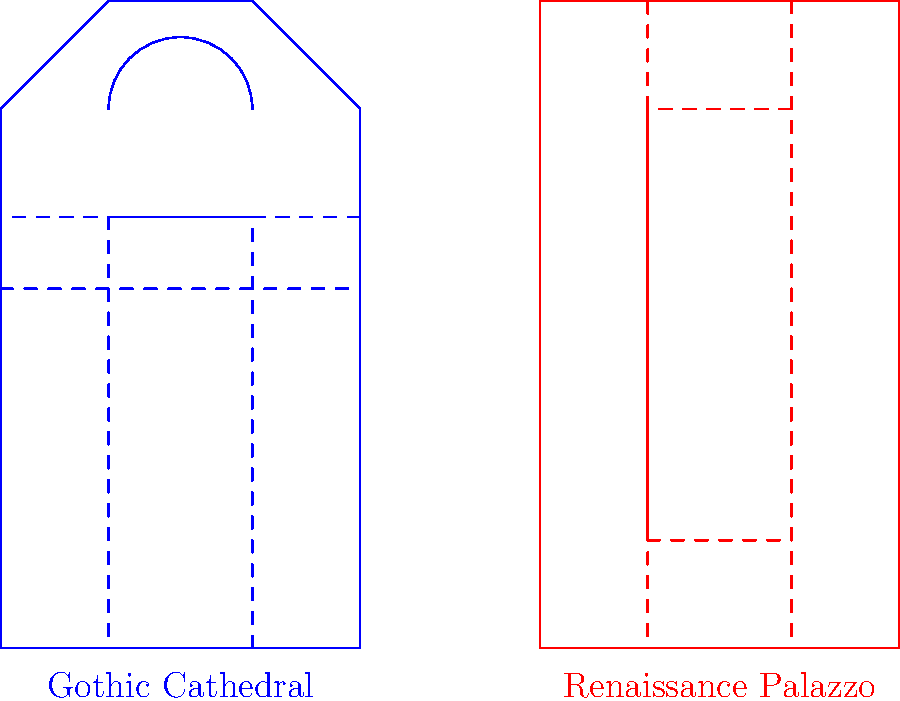Compare and contrast the floor plans of the Gothic Cathedral (left) and the Renaissance Palazzo (right) shown in the diagram. How do these architectural layouts reflect the cultural and societal values of their respective time periods? Discuss at least three key differences in their spatial organization and overall design philosophy. To compare and contrast these floor plans, we need to consider several key aspects:

1. Overall Shape:
   - Gothic Cathedral: Cruciform shape with a long nave, transepts, and apse.
   - Renaissance Palazzo: Rectangular shape with a central courtyard.

2. Spatial Organization:
   - Gothic Cathedral: 
     a) Linear progression from entrance to altar
     b) Hierarchical spaces (nave, transepts, apse)
     c) Emphasis on vertical space (not shown in plan, but implied)
   - Renaissance Palazzo:
     a) Rooms arranged around a central courtyard
     b) More equal distribution of spaces
     c) Emphasis on symmetry and proportion

3. Purpose and Function:
   - Gothic Cathedral: 
     a) Designed for religious worship and to inspire awe
     b) Large open spaces for congregations
     c) Apse for liturgical functions
   - Renaissance Palazzo:
     a) Designed for aristocratic living and entertaining
     b) Multiple smaller rooms for various functions
     c) Central courtyard for light, air, and social gatherings

4. Cultural Values Reflected:
   - Gothic Cathedral:
     a) Focus on spirituality and connection to the divine
     b) Grandeur and monumentality to glorify God
     c) Community-oriented space for collective worship
   - Renaissance Palazzo:
     a) Emphasis on humanism and secular life
     b) Importance of symmetry, order, and rational design
     c) Privacy and comfort for the individual or family

5. Historical Context:
   - Gothic Cathedral: 12th-16th centuries, dominated by religious institutions
   - Renaissance Palazzo: 15th-16th centuries, rise of merchant class and humanism

These differences reflect the shift from the Medieval period's focus on religion and community to the Renaissance's emphasis on individualism, classical learning, and secular power.
Answer: Gothic Cathedrals reflect medieval religious values through cruciform plans, hierarchical spaces, and vertical emphasis, while Renaissance Palazzos embody humanist ideals with symmetrical layouts, central courtyards, and focus on individual comfort and secular living. 